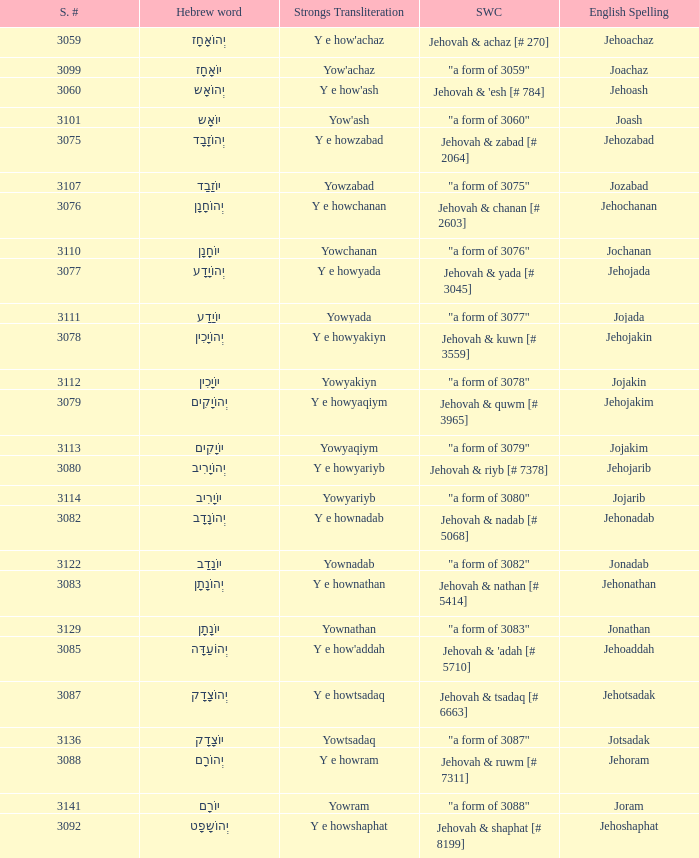What is the strong words compounded when the strongs transliteration is yowyariyb? "a form of 3080". 